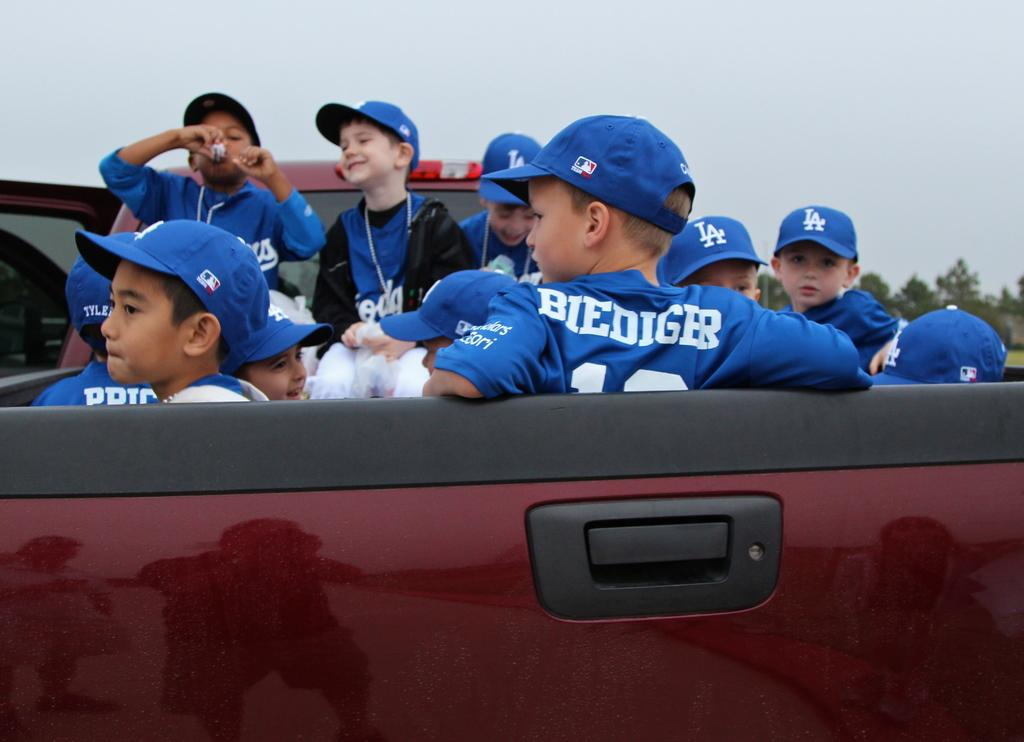<image>
Summarize the visual content of the image. Baseball players in a van with one whose jersey says Biediger. 